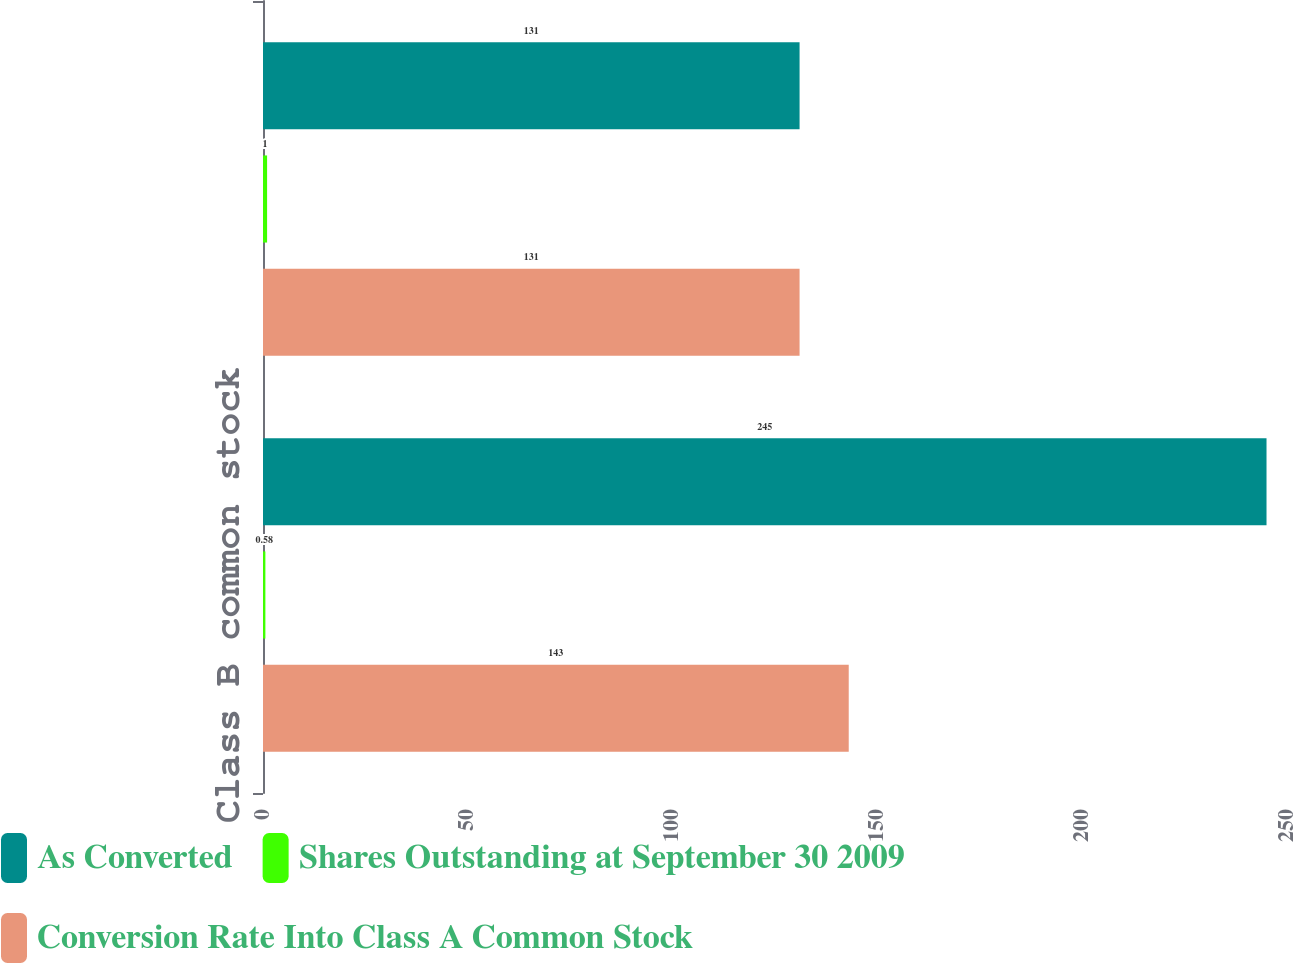Convert chart to OTSL. <chart><loc_0><loc_0><loc_500><loc_500><stacked_bar_chart><ecel><fcel>Class B common stock<fcel>Class C common stock<nl><fcel>As Converted<fcel>245<fcel>131<nl><fcel>Shares Outstanding at September 30 2009<fcel>0.58<fcel>1<nl><fcel>Conversion Rate Into Class A Common Stock<fcel>143<fcel>131<nl></chart> 